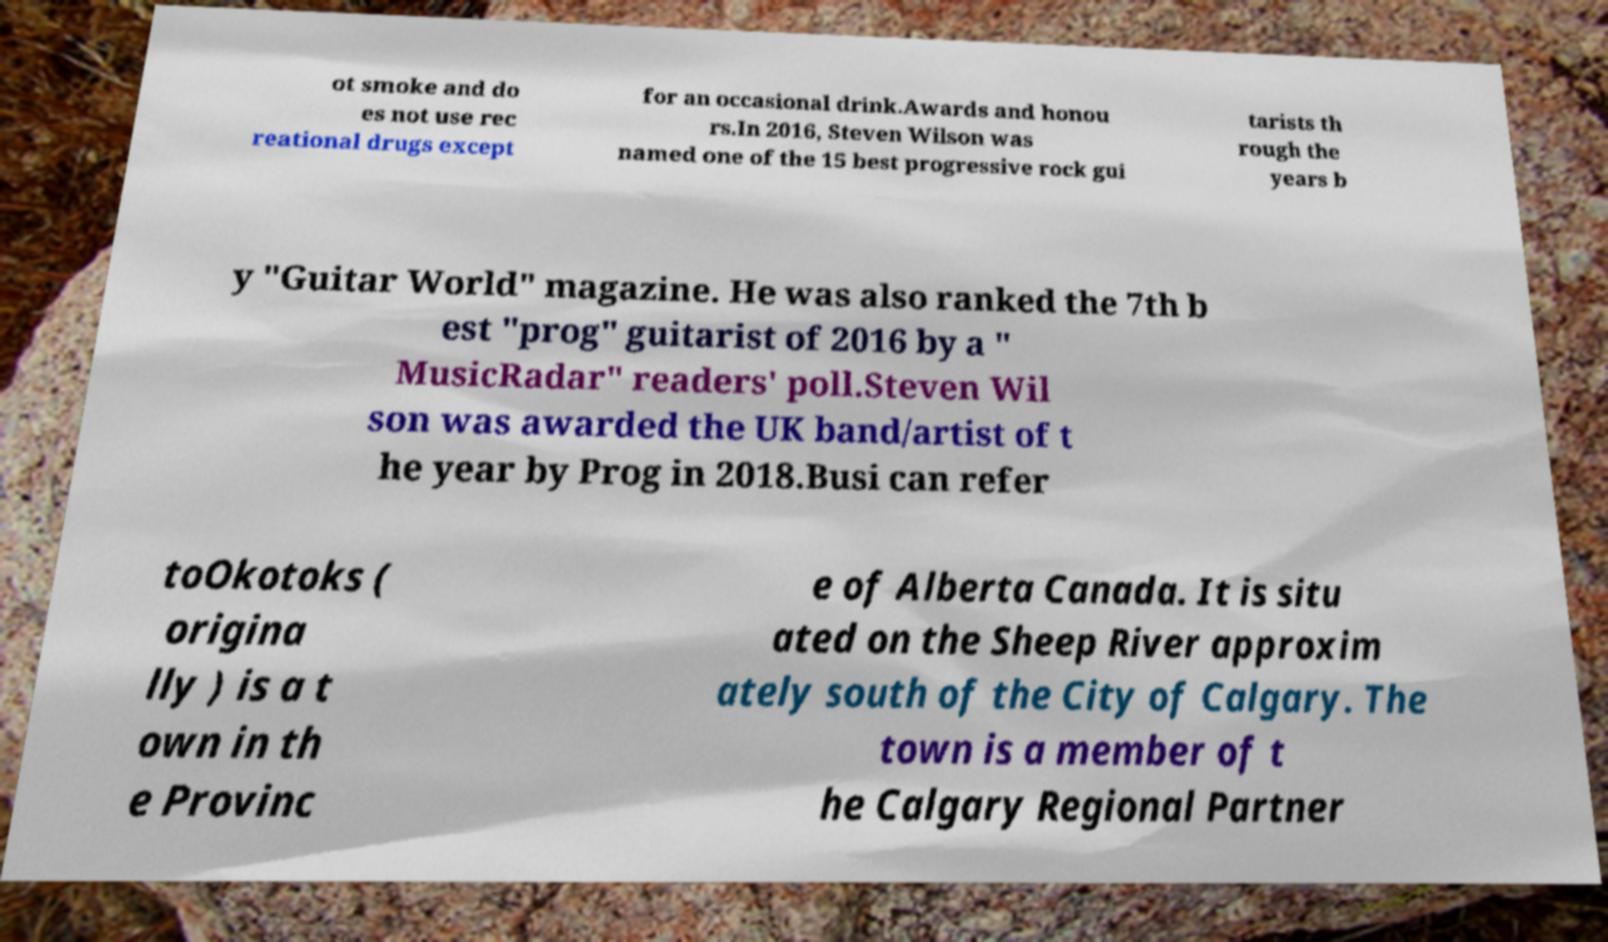Could you extract and type out the text from this image? ot smoke and do es not use rec reational drugs except for an occasional drink.Awards and honou rs.In 2016, Steven Wilson was named one of the 15 best progressive rock gui tarists th rough the years b y "Guitar World" magazine. He was also ranked the 7th b est "prog" guitarist of 2016 by a " MusicRadar" readers' poll.Steven Wil son was awarded the UK band/artist of t he year by Prog in 2018.Busi can refer toOkotoks ( origina lly ) is a t own in th e Provinc e of Alberta Canada. It is situ ated on the Sheep River approxim ately south of the City of Calgary. The town is a member of t he Calgary Regional Partner 